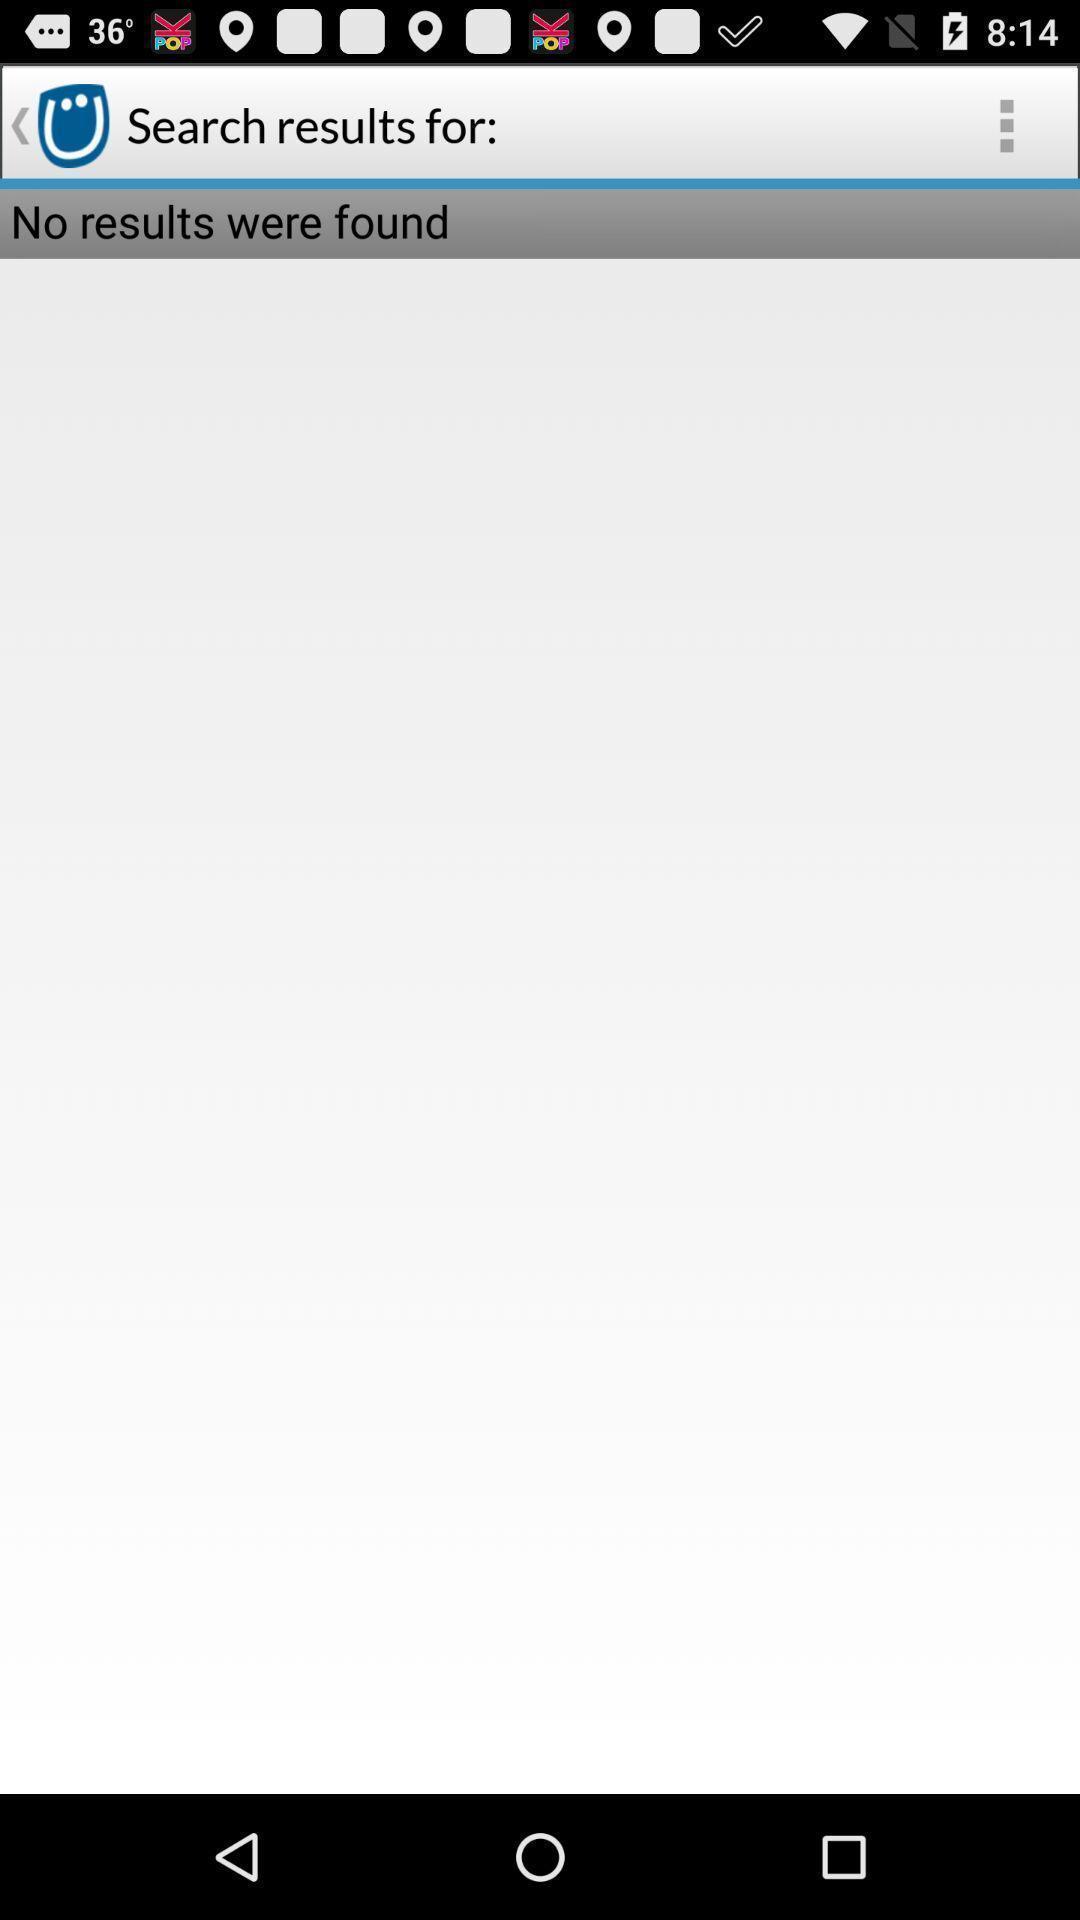What can you discern from this picture? Screen displaying the search results page which is empty. 